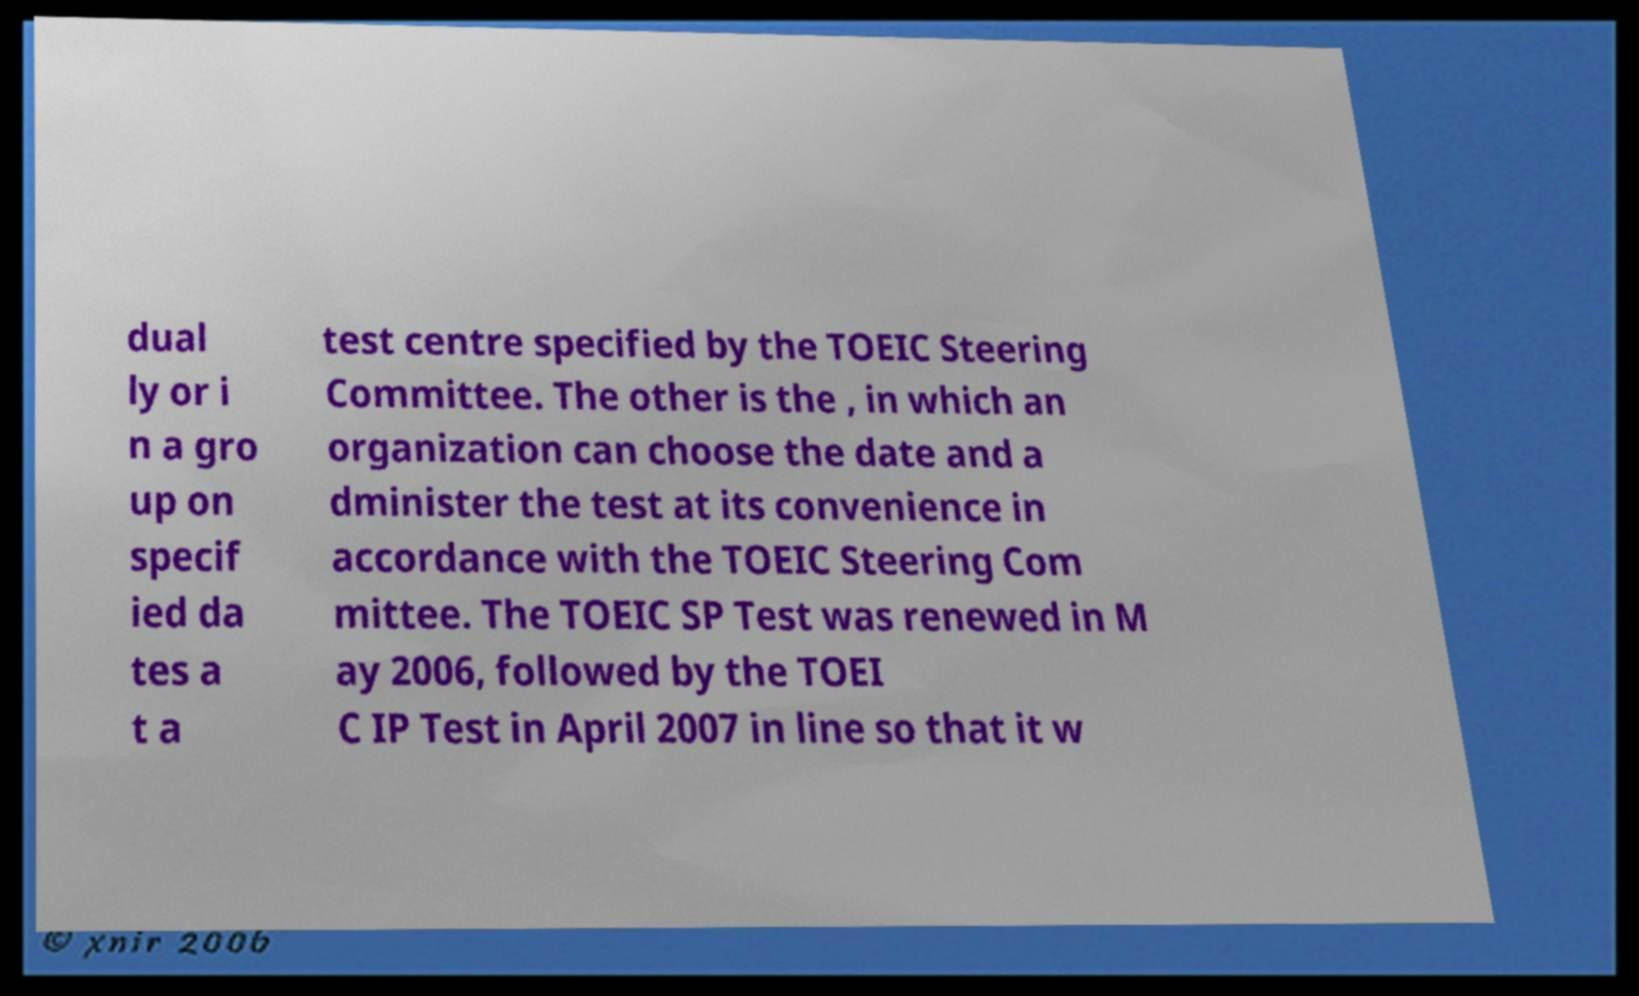There's text embedded in this image that I need extracted. Can you transcribe it verbatim? dual ly or i n a gro up on specif ied da tes a t a test centre specified by the TOEIC Steering Committee. The other is the , in which an organization can choose the date and a dminister the test at its convenience in accordance with the TOEIC Steering Com mittee. The TOEIC SP Test was renewed in M ay 2006, followed by the TOEI C IP Test in April 2007 in line so that it w 